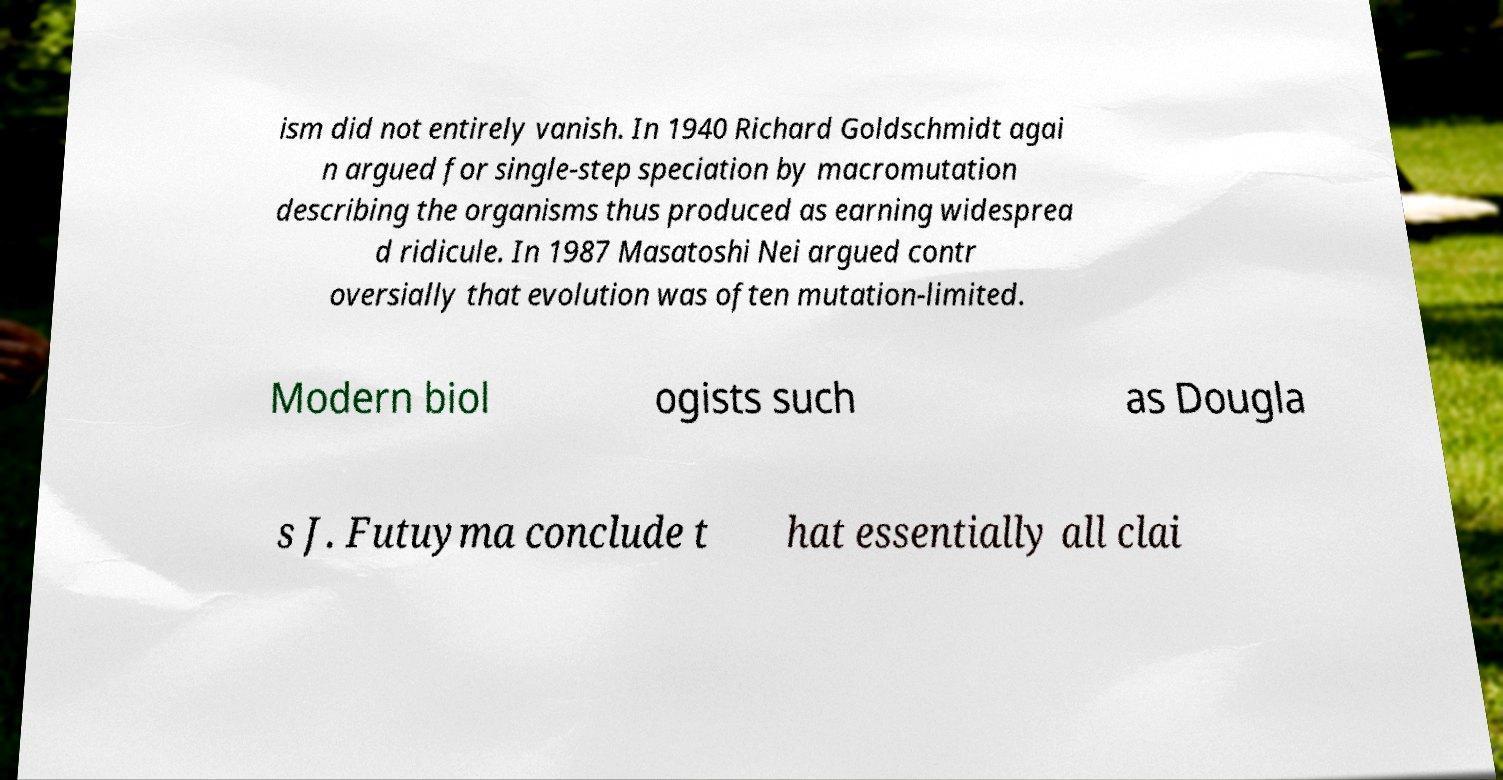What messages or text are displayed in this image? I need them in a readable, typed format. ism did not entirely vanish. In 1940 Richard Goldschmidt agai n argued for single-step speciation by macromutation describing the organisms thus produced as earning widesprea d ridicule. In 1987 Masatoshi Nei argued contr oversially that evolution was often mutation-limited. Modern biol ogists such as Dougla s J. Futuyma conclude t hat essentially all clai 